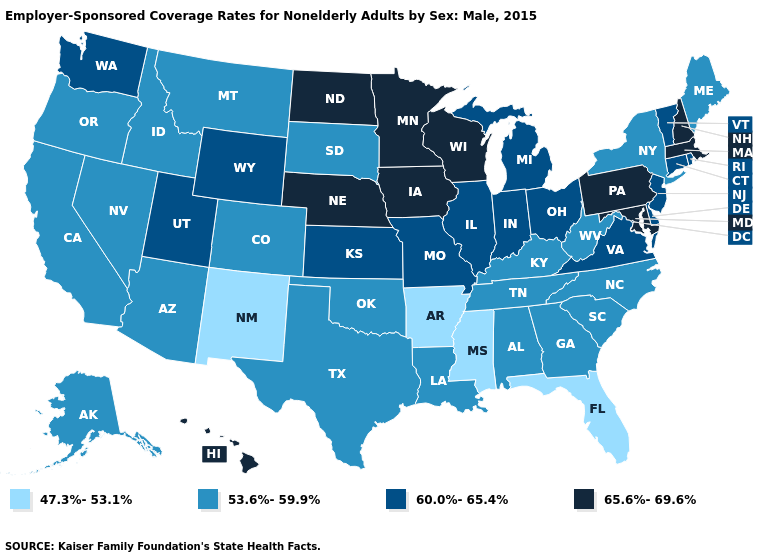What is the value of Montana?
Answer briefly. 53.6%-59.9%. Does Oklahoma have the lowest value in the South?
Short answer required. No. How many symbols are there in the legend?
Be succinct. 4. Does New York have a lower value than Maryland?
Quick response, please. Yes. How many symbols are there in the legend?
Be succinct. 4. What is the highest value in states that border Illinois?
Answer briefly. 65.6%-69.6%. Name the states that have a value in the range 53.6%-59.9%?
Write a very short answer. Alabama, Alaska, Arizona, California, Colorado, Georgia, Idaho, Kentucky, Louisiana, Maine, Montana, Nevada, New York, North Carolina, Oklahoma, Oregon, South Carolina, South Dakota, Tennessee, Texas, West Virginia. Name the states that have a value in the range 65.6%-69.6%?
Quick response, please. Hawaii, Iowa, Maryland, Massachusetts, Minnesota, Nebraska, New Hampshire, North Dakota, Pennsylvania, Wisconsin. Which states hav the highest value in the South?
Concise answer only. Maryland. Name the states that have a value in the range 53.6%-59.9%?
Answer briefly. Alabama, Alaska, Arizona, California, Colorado, Georgia, Idaho, Kentucky, Louisiana, Maine, Montana, Nevada, New York, North Carolina, Oklahoma, Oregon, South Carolina, South Dakota, Tennessee, Texas, West Virginia. Does the first symbol in the legend represent the smallest category?
Give a very brief answer. Yes. Does Delaware have the lowest value in the USA?
Be succinct. No. Among the states that border Iowa , does Nebraska have the lowest value?
Quick response, please. No. What is the highest value in the Northeast ?
Give a very brief answer. 65.6%-69.6%. What is the value of Hawaii?
Give a very brief answer. 65.6%-69.6%. 